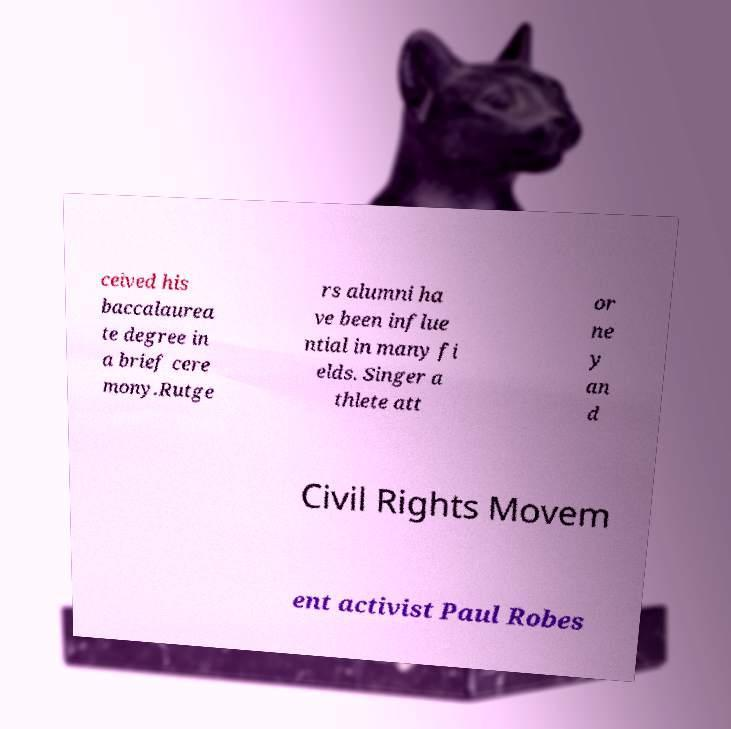Can you read and provide the text displayed in the image?This photo seems to have some interesting text. Can you extract and type it out for me? ceived his baccalaurea te degree in a brief cere mony.Rutge rs alumni ha ve been influe ntial in many fi elds. Singer a thlete att or ne y an d Civil Rights Movem ent activist Paul Robes 